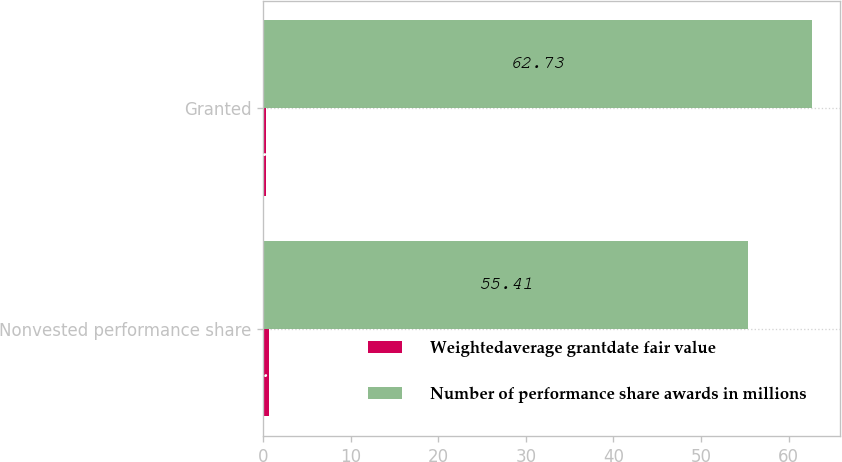<chart> <loc_0><loc_0><loc_500><loc_500><stacked_bar_chart><ecel><fcel>Nonvested performance share<fcel>Granted<nl><fcel>Weightedaverage grantdate fair value<fcel>0.7<fcel>0.3<nl><fcel>Number of performance share awards in millions<fcel>55.41<fcel>62.73<nl></chart> 